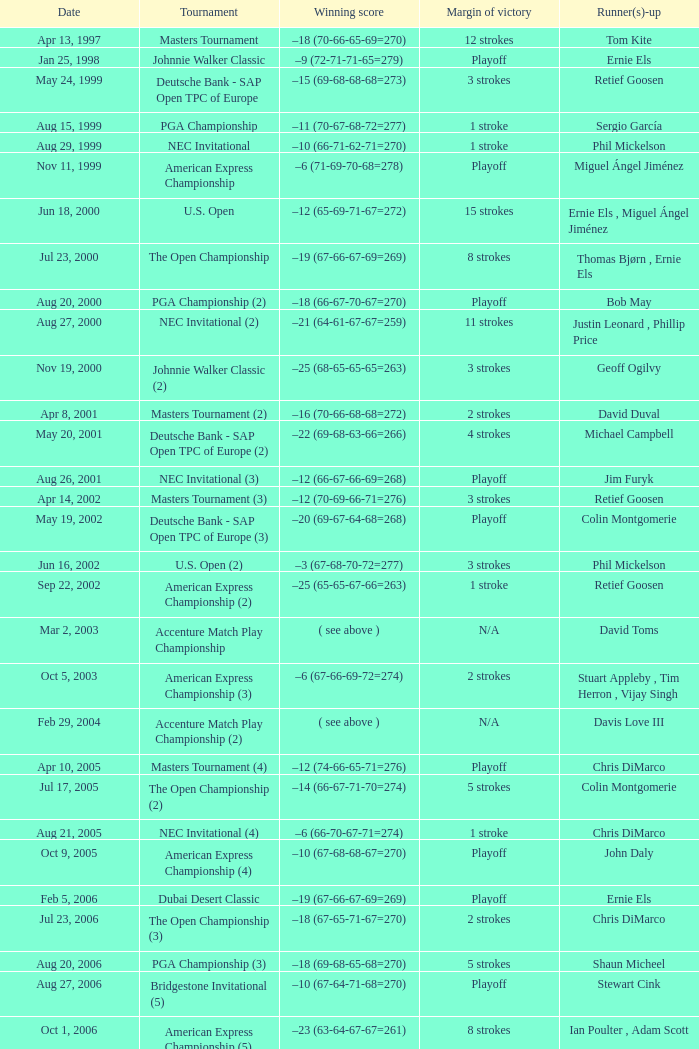Which contest has a victory margin of 7 strokes? Bridgestone Invitational (8). 